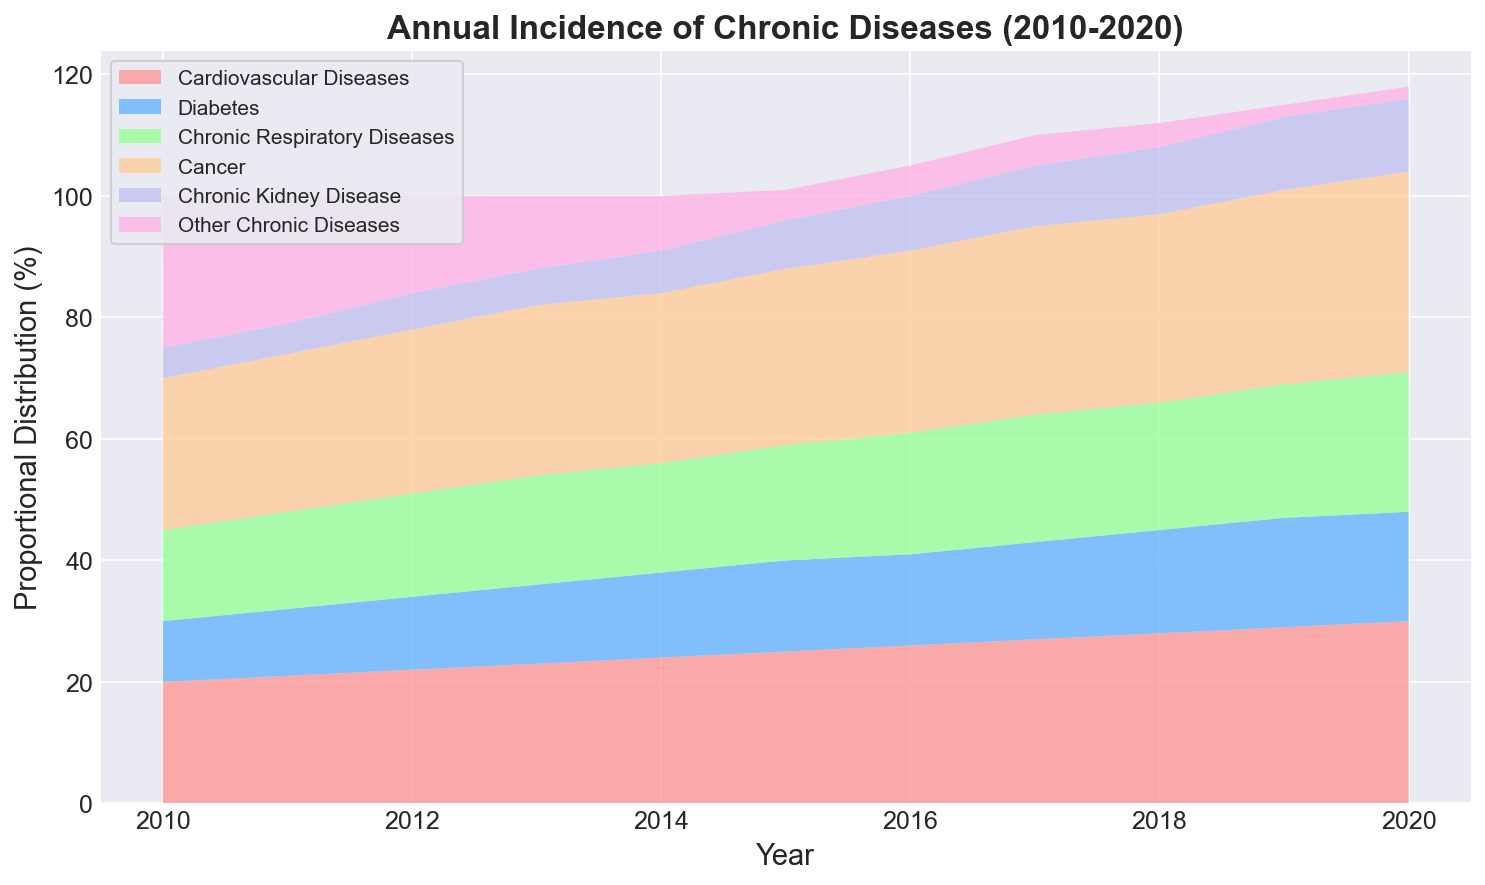What year had the highest total incidence of chronic diseases? To find the highest total incidence year, we observe the height of the stacked area chart for each year. The highest peak occurs in 2020.
Answer: 2020 How did the incidence of Cardiovascular Diseases change from 2010 to 2020? The incidence went from 20% in 2010 to 30% in 2020, showing a consistent increase of 10 percentage points over the decade.
Answer: Increased by 10 percentage points Which disease type had the smallest percentage change from 2010 to 2020? Observing all disease types, "Other Chronic Diseases" started at 25% in 2010 and decreased to 2% by 2020, while other categories have more significant changes.
Answer: Other Chronic Diseases Compare the incidence of Diabetes and Chronic Respiratory Diseases in 2015. Which was higher? We check the values for 2015: Diabetes was 15%, and Chronic Respiratory Diseases was 19%. Thus, Chronic Respiratory Diseases had a higher incidence.
Answer: Chronic Respiratory Diseases Combining all disease categories, what is the total increase in incidence from 2010 to 2020? Given that the sum must be 100% each year, the overall incidence does not increase.
Answer: 0% increase Between which consecutive years did Cancer incidence see the most significant increase? Checking each year for increments, the most significant increase in Cancer is from 2010 (25%) to 2011 (26%), an increase of 1 percentage point.
Answer: 2010-2011 Which disease type showed the largest absolute decrease over the entire period? From the chart, "Other Chronic Diseases" decreased from 25% in 2010 to 2% in 2020, which is a 23 percentage point decrease.
Answer: Other Chronic Diseases In 2019, how does the incidence of Chronic Kidney Disease compare to that of Cardiovascular Diseases? In 2019, Chronic Kidney Disease is at 12% and Cardiovascular Diseases are at 29%, showing that Cardiovascular Diseases have a much higher incidence.
Answer: Cardiovascular Diseases are higher What is the average annual increase in Cancer incidence over the decade? Cancer incidence goes from 25% in 2010 to 33% in 2020, an overall increase of 8 percentage points. Thus, the average annual increase is 8/10 = 0.8%.
Answer: 0.8% What is the cumulative incidence of Cancer and Cardiovascular Diseases in 2015? In 2015, Cancer is at 29% and Cardiovascular Diseases at 25%. Adding them gives 29 + 25 = 54%.
Answer: 54% 